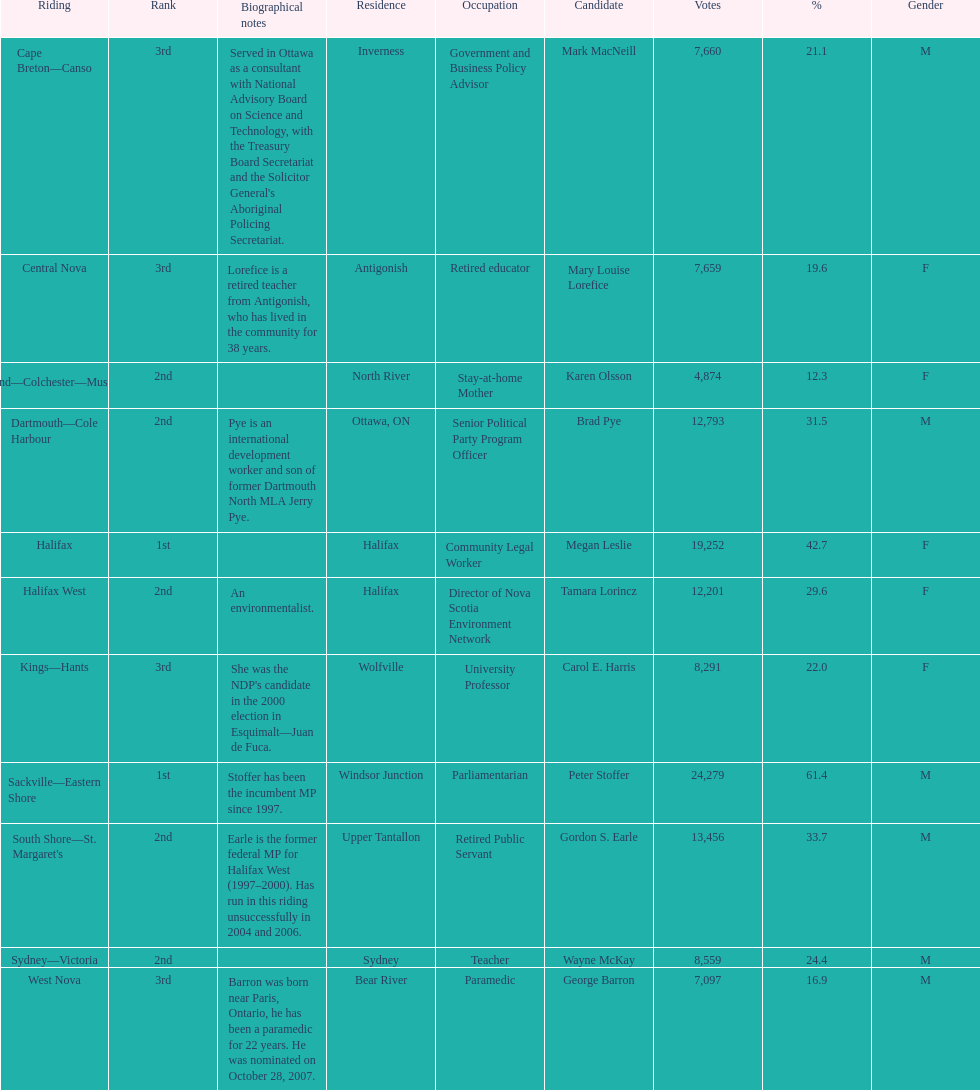What is the number of votes that megan leslie received? 19,252. 